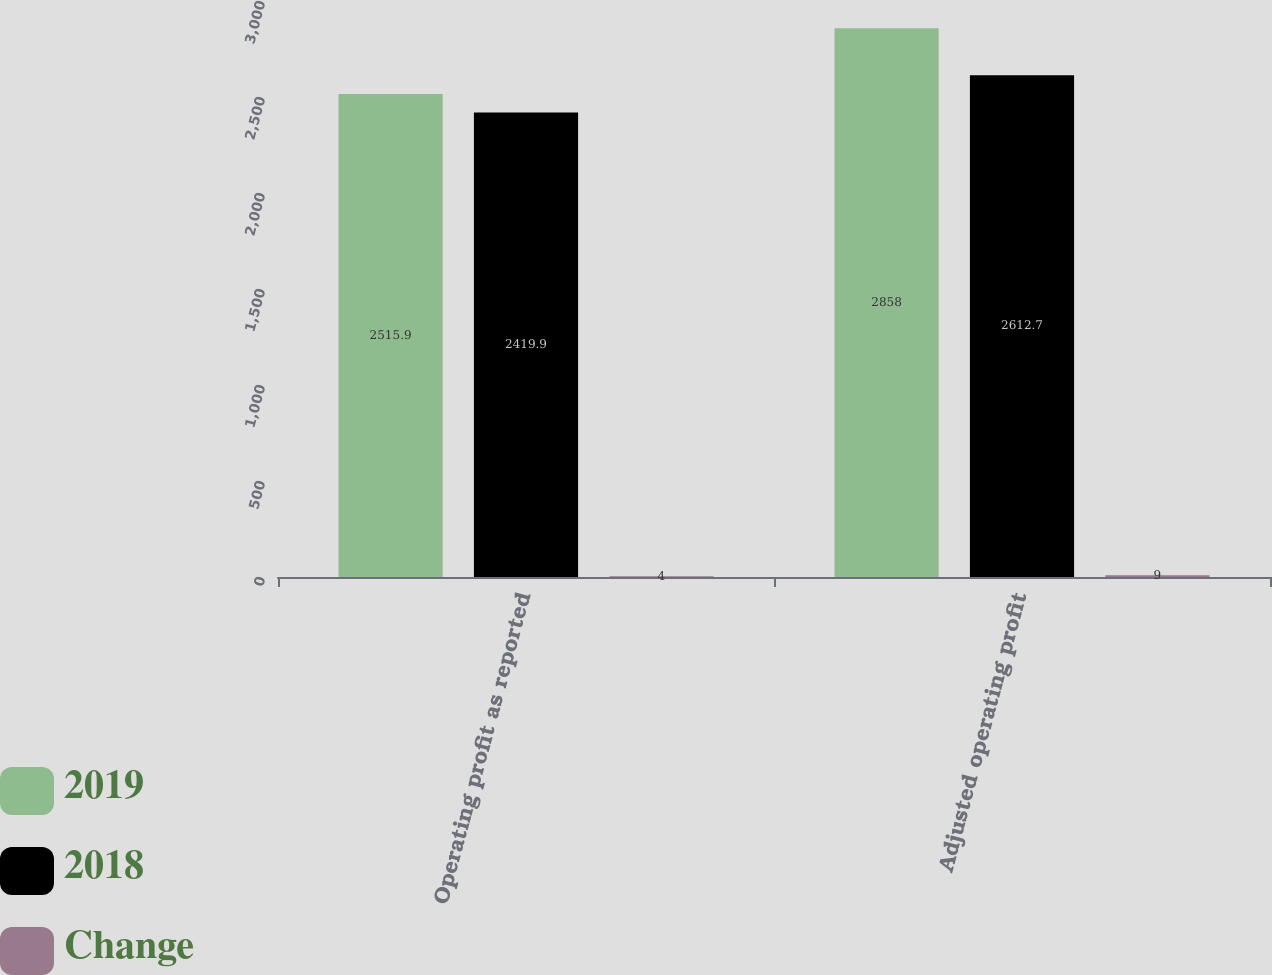Convert chart to OTSL. <chart><loc_0><loc_0><loc_500><loc_500><stacked_bar_chart><ecel><fcel>Operating profit as reported<fcel>Adjusted operating profit<nl><fcel>2019<fcel>2515.9<fcel>2858<nl><fcel>2018<fcel>2419.9<fcel>2612.7<nl><fcel>Change<fcel>4<fcel>9<nl></chart> 